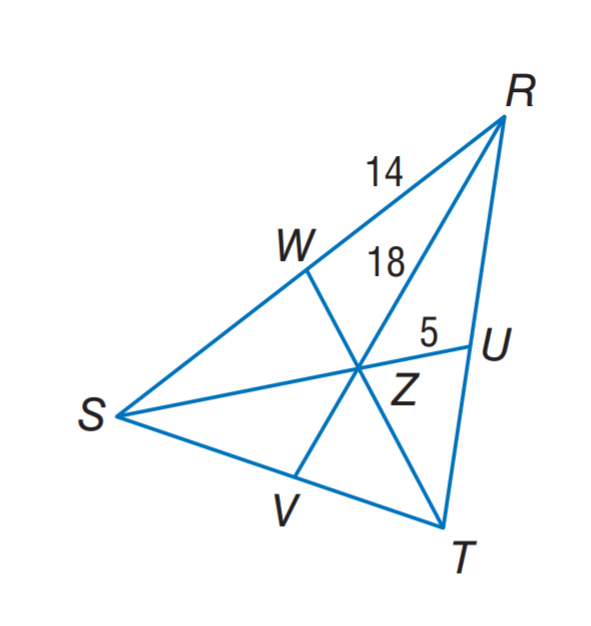Answer the mathemtical geometry problem and directly provide the correct option letter.
Question: In \triangle R S T, Z is the centroid and R Z = 18. Find S Z.
Choices: A: 5 B: 9 C: 10 D: 18 C 